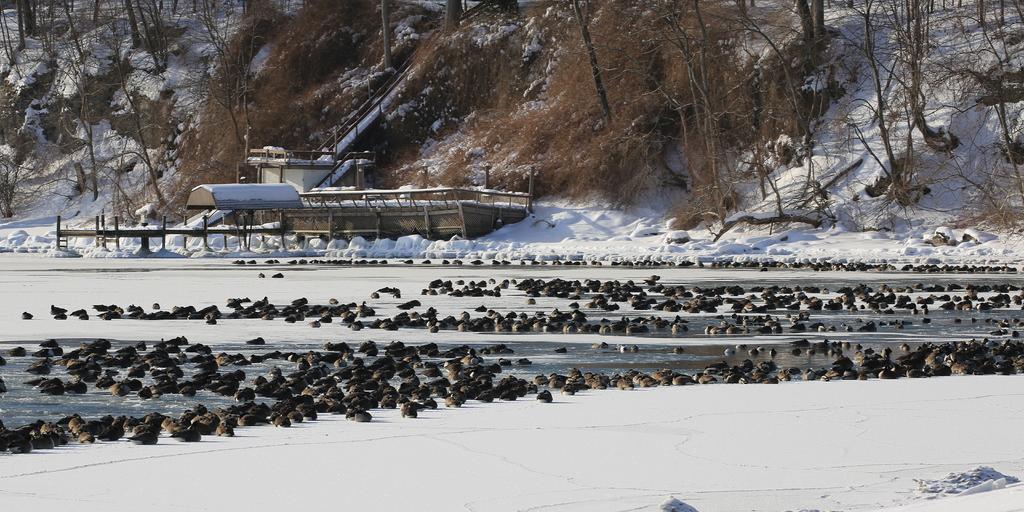Describe this image in one or two sentences. In this image in the center there are aquatic animals in the water. In the front there is snow. In the background there are trees and there is a wooden shelter. 